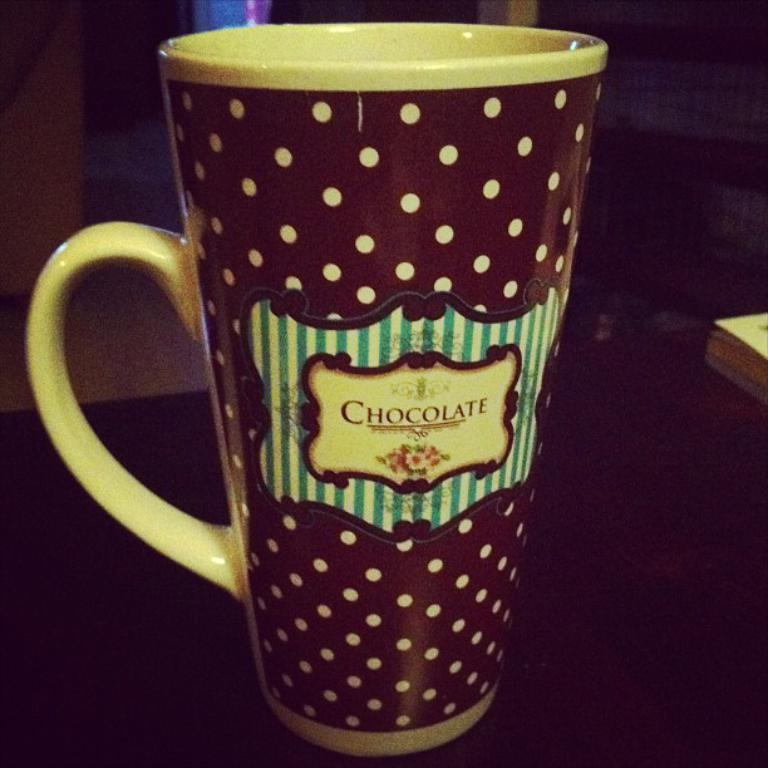<image>
Summarize the visual content of the image. Tall ceramic brown with yellow polka dotted coffee mug that says chocolate on the frton. 